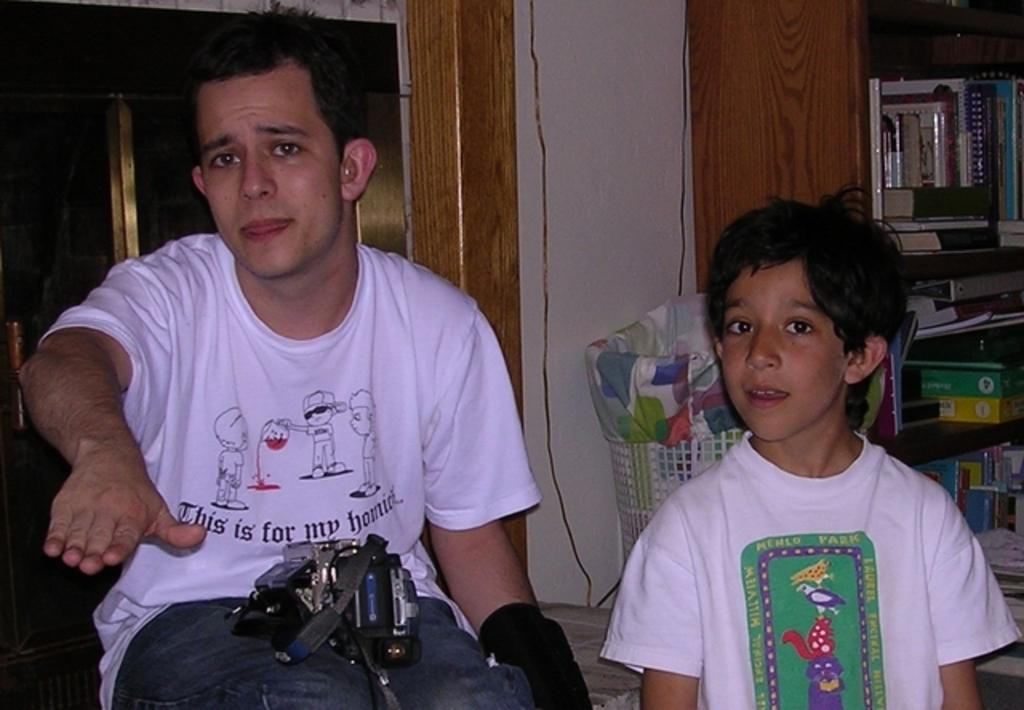What is the man in the image doing? The man is sitting in the image. What is the man holding in the image? The man is holding an object. Who is standing beside the man in the image? There is a boy standing beside the man in the image. What can be seen in the background of the image? In the background of the image, there is a basket, books, objects in racks, and a wall. How many rabbits can be seen touching the loss in the image? There are no rabbits or any reference to loss in the image. 